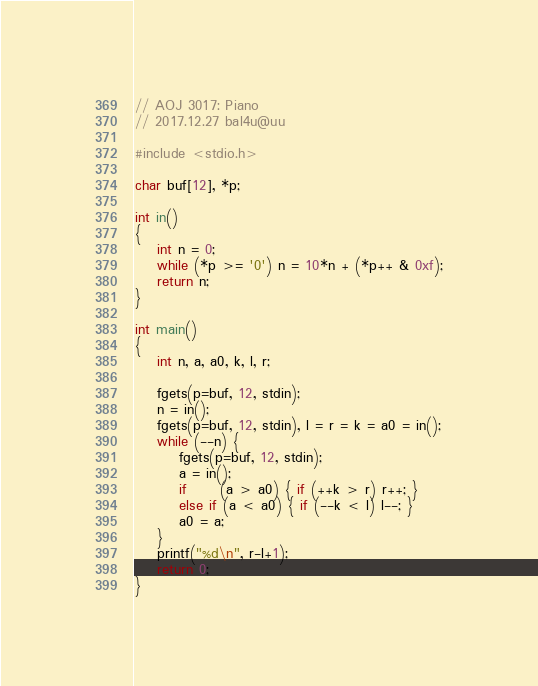<code> <loc_0><loc_0><loc_500><loc_500><_C_>// AOJ 3017: Piano
// 2017.12.27 bal4u@uu

#include <stdio.h>

char buf[12], *p;

int in()
{
	int n = 0;
	while (*p >= '0') n = 10*n + (*p++ & 0xf);
	return n;
}

int main()
{
	int n, a, a0, k, l, r;

	fgets(p=buf, 12, stdin);
	n = in();
	fgets(p=buf, 12, stdin), l = r = k = a0 = in();
	while (--n) {
		fgets(p=buf, 12, stdin);
		a = in();
		if      (a > a0) { if (++k > r) r++; }
		else if (a < a0) { if (--k < l) l--; }
		a0 = a;
	}
	printf("%d\n", r-l+1);
	return 0;
}</code> 